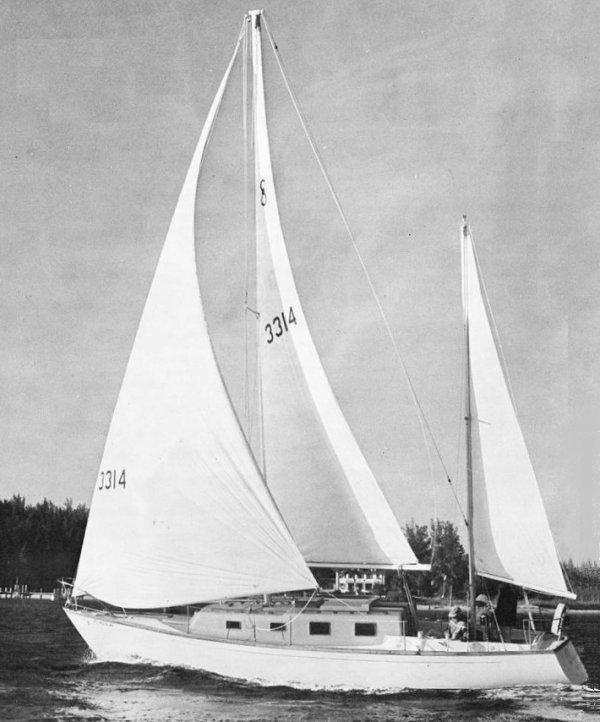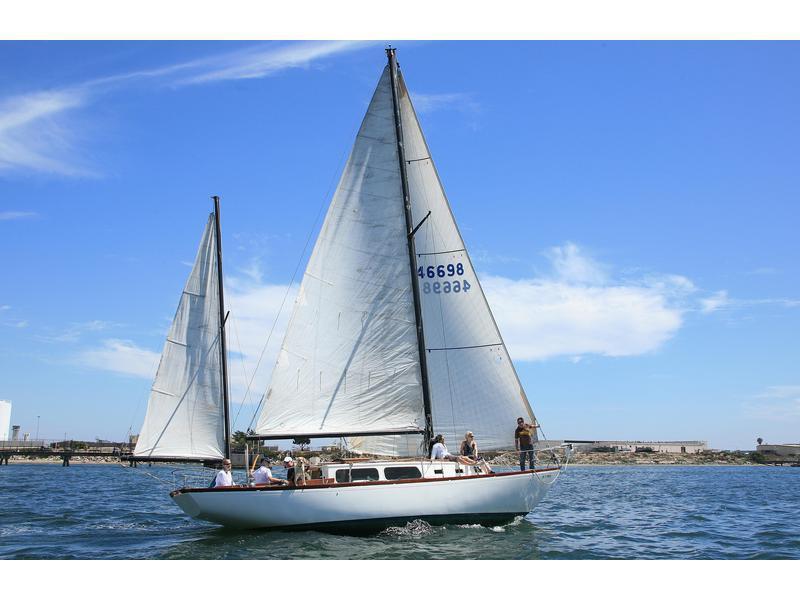The first image is the image on the left, the second image is the image on the right. Considering the images on both sides, is "The left image shows a rightward-facing boat with a colored border on its leading unfurled sail and at least one colored canopy." valid? Answer yes or no. No. 